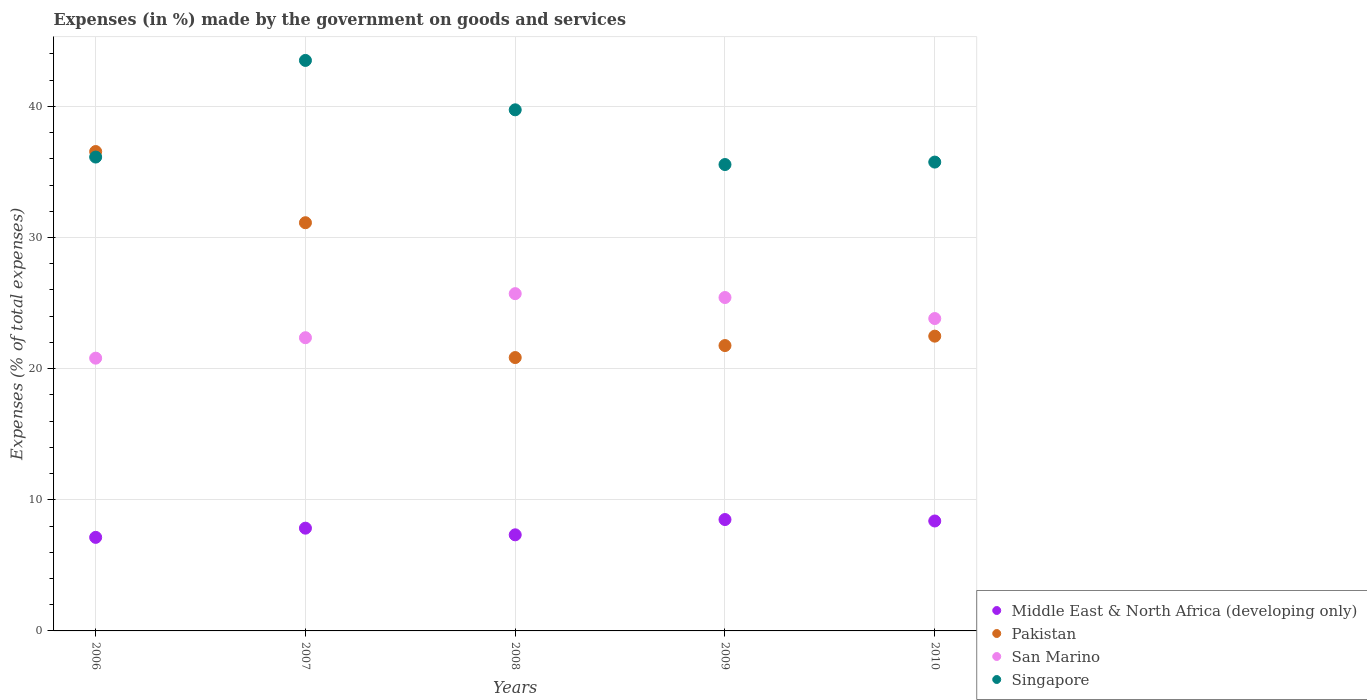What is the percentage of expenses made by the government on goods and services in San Marino in 2009?
Make the answer very short. 25.43. Across all years, what is the maximum percentage of expenses made by the government on goods and services in Pakistan?
Give a very brief answer. 36.56. Across all years, what is the minimum percentage of expenses made by the government on goods and services in Pakistan?
Provide a succinct answer. 20.85. In which year was the percentage of expenses made by the government on goods and services in San Marino minimum?
Keep it short and to the point. 2006. What is the total percentage of expenses made by the government on goods and services in Middle East & North Africa (developing only) in the graph?
Ensure brevity in your answer.  39.18. What is the difference between the percentage of expenses made by the government on goods and services in Middle East & North Africa (developing only) in 2006 and that in 2009?
Your response must be concise. -1.36. What is the difference between the percentage of expenses made by the government on goods and services in Middle East & North Africa (developing only) in 2006 and the percentage of expenses made by the government on goods and services in Singapore in 2010?
Offer a very short reply. -28.62. What is the average percentage of expenses made by the government on goods and services in Singapore per year?
Provide a short and direct response. 38.14. In the year 2010, what is the difference between the percentage of expenses made by the government on goods and services in Singapore and percentage of expenses made by the government on goods and services in Middle East & North Africa (developing only)?
Offer a very short reply. 27.37. What is the ratio of the percentage of expenses made by the government on goods and services in San Marino in 2008 to that in 2010?
Your response must be concise. 1.08. What is the difference between the highest and the second highest percentage of expenses made by the government on goods and services in Singapore?
Make the answer very short. 3.77. What is the difference between the highest and the lowest percentage of expenses made by the government on goods and services in Middle East & North Africa (developing only)?
Make the answer very short. 1.36. In how many years, is the percentage of expenses made by the government on goods and services in San Marino greater than the average percentage of expenses made by the government on goods and services in San Marino taken over all years?
Your answer should be very brief. 3. Is it the case that in every year, the sum of the percentage of expenses made by the government on goods and services in Middle East & North Africa (developing only) and percentage of expenses made by the government on goods and services in Pakistan  is greater than the sum of percentage of expenses made by the government on goods and services in Singapore and percentage of expenses made by the government on goods and services in San Marino?
Ensure brevity in your answer.  Yes. Does the percentage of expenses made by the government on goods and services in Middle East & North Africa (developing only) monotonically increase over the years?
Offer a terse response. No. Is the percentage of expenses made by the government on goods and services in San Marino strictly greater than the percentage of expenses made by the government on goods and services in Singapore over the years?
Offer a very short reply. No. How many dotlines are there?
Your answer should be very brief. 4. Does the graph contain grids?
Make the answer very short. Yes. Where does the legend appear in the graph?
Your answer should be compact. Bottom right. How are the legend labels stacked?
Keep it short and to the point. Vertical. What is the title of the graph?
Ensure brevity in your answer.  Expenses (in %) made by the government on goods and services. What is the label or title of the X-axis?
Keep it short and to the point. Years. What is the label or title of the Y-axis?
Offer a terse response. Expenses (% of total expenses). What is the Expenses (% of total expenses) of Middle East & North Africa (developing only) in 2006?
Keep it short and to the point. 7.13. What is the Expenses (% of total expenses) in Pakistan in 2006?
Your answer should be compact. 36.56. What is the Expenses (% of total expenses) of San Marino in 2006?
Make the answer very short. 20.8. What is the Expenses (% of total expenses) in Singapore in 2006?
Offer a very short reply. 36.14. What is the Expenses (% of total expenses) in Middle East & North Africa (developing only) in 2007?
Make the answer very short. 7.84. What is the Expenses (% of total expenses) of Pakistan in 2007?
Your answer should be very brief. 31.13. What is the Expenses (% of total expenses) of San Marino in 2007?
Your answer should be very brief. 22.36. What is the Expenses (% of total expenses) in Singapore in 2007?
Provide a succinct answer. 43.51. What is the Expenses (% of total expenses) in Middle East & North Africa (developing only) in 2008?
Offer a terse response. 7.33. What is the Expenses (% of total expenses) in Pakistan in 2008?
Keep it short and to the point. 20.85. What is the Expenses (% of total expenses) of San Marino in 2008?
Your response must be concise. 25.72. What is the Expenses (% of total expenses) of Singapore in 2008?
Provide a short and direct response. 39.74. What is the Expenses (% of total expenses) of Middle East & North Africa (developing only) in 2009?
Keep it short and to the point. 8.49. What is the Expenses (% of total expenses) in Pakistan in 2009?
Your answer should be very brief. 21.76. What is the Expenses (% of total expenses) of San Marino in 2009?
Provide a short and direct response. 25.43. What is the Expenses (% of total expenses) of Singapore in 2009?
Your response must be concise. 35.57. What is the Expenses (% of total expenses) of Middle East & North Africa (developing only) in 2010?
Your answer should be very brief. 8.38. What is the Expenses (% of total expenses) of Pakistan in 2010?
Your response must be concise. 22.48. What is the Expenses (% of total expenses) of San Marino in 2010?
Ensure brevity in your answer.  23.82. What is the Expenses (% of total expenses) of Singapore in 2010?
Provide a short and direct response. 35.75. Across all years, what is the maximum Expenses (% of total expenses) of Middle East & North Africa (developing only)?
Offer a very short reply. 8.49. Across all years, what is the maximum Expenses (% of total expenses) in Pakistan?
Give a very brief answer. 36.56. Across all years, what is the maximum Expenses (% of total expenses) of San Marino?
Offer a terse response. 25.72. Across all years, what is the maximum Expenses (% of total expenses) of Singapore?
Keep it short and to the point. 43.51. Across all years, what is the minimum Expenses (% of total expenses) of Middle East & North Africa (developing only)?
Your response must be concise. 7.13. Across all years, what is the minimum Expenses (% of total expenses) of Pakistan?
Keep it short and to the point. 20.85. Across all years, what is the minimum Expenses (% of total expenses) of San Marino?
Make the answer very short. 20.8. Across all years, what is the minimum Expenses (% of total expenses) of Singapore?
Your response must be concise. 35.57. What is the total Expenses (% of total expenses) of Middle East & North Africa (developing only) in the graph?
Your answer should be very brief. 39.18. What is the total Expenses (% of total expenses) in Pakistan in the graph?
Offer a terse response. 132.78. What is the total Expenses (% of total expenses) in San Marino in the graph?
Give a very brief answer. 118.13. What is the total Expenses (% of total expenses) in Singapore in the graph?
Provide a succinct answer. 190.71. What is the difference between the Expenses (% of total expenses) of Middle East & North Africa (developing only) in 2006 and that in 2007?
Your answer should be very brief. -0.7. What is the difference between the Expenses (% of total expenses) in Pakistan in 2006 and that in 2007?
Your answer should be compact. 5.43. What is the difference between the Expenses (% of total expenses) of San Marino in 2006 and that in 2007?
Give a very brief answer. -1.56. What is the difference between the Expenses (% of total expenses) in Singapore in 2006 and that in 2007?
Offer a terse response. -7.37. What is the difference between the Expenses (% of total expenses) in Middle East & North Africa (developing only) in 2006 and that in 2008?
Offer a very short reply. -0.19. What is the difference between the Expenses (% of total expenses) of Pakistan in 2006 and that in 2008?
Offer a very short reply. 15.71. What is the difference between the Expenses (% of total expenses) in San Marino in 2006 and that in 2008?
Give a very brief answer. -4.92. What is the difference between the Expenses (% of total expenses) of Singapore in 2006 and that in 2008?
Your response must be concise. -3.6. What is the difference between the Expenses (% of total expenses) in Middle East & North Africa (developing only) in 2006 and that in 2009?
Provide a short and direct response. -1.36. What is the difference between the Expenses (% of total expenses) in Pakistan in 2006 and that in 2009?
Your answer should be very brief. 14.8. What is the difference between the Expenses (% of total expenses) of San Marino in 2006 and that in 2009?
Offer a terse response. -4.62. What is the difference between the Expenses (% of total expenses) of Singapore in 2006 and that in 2009?
Your answer should be compact. 0.57. What is the difference between the Expenses (% of total expenses) of Middle East & North Africa (developing only) in 2006 and that in 2010?
Provide a short and direct response. -1.25. What is the difference between the Expenses (% of total expenses) of Pakistan in 2006 and that in 2010?
Your answer should be very brief. 14.08. What is the difference between the Expenses (% of total expenses) in San Marino in 2006 and that in 2010?
Offer a very short reply. -3.02. What is the difference between the Expenses (% of total expenses) in Singapore in 2006 and that in 2010?
Keep it short and to the point. 0.38. What is the difference between the Expenses (% of total expenses) of Middle East & North Africa (developing only) in 2007 and that in 2008?
Your answer should be compact. 0.51. What is the difference between the Expenses (% of total expenses) in Pakistan in 2007 and that in 2008?
Keep it short and to the point. 10.28. What is the difference between the Expenses (% of total expenses) of San Marino in 2007 and that in 2008?
Your answer should be very brief. -3.36. What is the difference between the Expenses (% of total expenses) in Singapore in 2007 and that in 2008?
Keep it short and to the point. 3.77. What is the difference between the Expenses (% of total expenses) of Middle East & North Africa (developing only) in 2007 and that in 2009?
Provide a succinct answer. -0.66. What is the difference between the Expenses (% of total expenses) of Pakistan in 2007 and that in 2009?
Give a very brief answer. 9.37. What is the difference between the Expenses (% of total expenses) of San Marino in 2007 and that in 2009?
Provide a succinct answer. -3.07. What is the difference between the Expenses (% of total expenses) in Singapore in 2007 and that in 2009?
Offer a very short reply. 7.94. What is the difference between the Expenses (% of total expenses) of Middle East & North Africa (developing only) in 2007 and that in 2010?
Keep it short and to the point. -0.55. What is the difference between the Expenses (% of total expenses) of Pakistan in 2007 and that in 2010?
Provide a succinct answer. 8.65. What is the difference between the Expenses (% of total expenses) of San Marino in 2007 and that in 2010?
Your answer should be very brief. -1.46. What is the difference between the Expenses (% of total expenses) in Singapore in 2007 and that in 2010?
Your response must be concise. 7.75. What is the difference between the Expenses (% of total expenses) of Middle East & North Africa (developing only) in 2008 and that in 2009?
Your answer should be compact. -1.17. What is the difference between the Expenses (% of total expenses) in Pakistan in 2008 and that in 2009?
Your answer should be compact. -0.92. What is the difference between the Expenses (% of total expenses) of San Marino in 2008 and that in 2009?
Give a very brief answer. 0.29. What is the difference between the Expenses (% of total expenses) in Singapore in 2008 and that in 2009?
Offer a terse response. 4.17. What is the difference between the Expenses (% of total expenses) in Middle East & North Africa (developing only) in 2008 and that in 2010?
Offer a terse response. -1.06. What is the difference between the Expenses (% of total expenses) of Pakistan in 2008 and that in 2010?
Your answer should be very brief. -1.63. What is the difference between the Expenses (% of total expenses) of San Marino in 2008 and that in 2010?
Offer a very short reply. 1.9. What is the difference between the Expenses (% of total expenses) of Singapore in 2008 and that in 2010?
Offer a very short reply. 3.99. What is the difference between the Expenses (% of total expenses) of Middle East & North Africa (developing only) in 2009 and that in 2010?
Ensure brevity in your answer.  0.11. What is the difference between the Expenses (% of total expenses) in Pakistan in 2009 and that in 2010?
Offer a terse response. -0.72. What is the difference between the Expenses (% of total expenses) of San Marino in 2009 and that in 2010?
Provide a succinct answer. 1.6. What is the difference between the Expenses (% of total expenses) in Singapore in 2009 and that in 2010?
Provide a succinct answer. -0.19. What is the difference between the Expenses (% of total expenses) of Middle East & North Africa (developing only) in 2006 and the Expenses (% of total expenses) of Pakistan in 2007?
Give a very brief answer. -24. What is the difference between the Expenses (% of total expenses) of Middle East & North Africa (developing only) in 2006 and the Expenses (% of total expenses) of San Marino in 2007?
Provide a succinct answer. -15.23. What is the difference between the Expenses (% of total expenses) of Middle East & North Africa (developing only) in 2006 and the Expenses (% of total expenses) of Singapore in 2007?
Your response must be concise. -36.37. What is the difference between the Expenses (% of total expenses) of Pakistan in 2006 and the Expenses (% of total expenses) of San Marino in 2007?
Provide a short and direct response. 14.2. What is the difference between the Expenses (% of total expenses) of Pakistan in 2006 and the Expenses (% of total expenses) of Singapore in 2007?
Ensure brevity in your answer.  -6.95. What is the difference between the Expenses (% of total expenses) of San Marino in 2006 and the Expenses (% of total expenses) of Singapore in 2007?
Provide a short and direct response. -22.71. What is the difference between the Expenses (% of total expenses) in Middle East & North Africa (developing only) in 2006 and the Expenses (% of total expenses) in Pakistan in 2008?
Provide a short and direct response. -13.71. What is the difference between the Expenses (% of total expenses) of Middle East & North Africa (developing only) in 2006 and the Expenses (% of total expenses) of San Marino in 2008?
Provide a succinct answer. -18.59. What is the difference between the Expenses (% of total expenses) of Middle East & North Africa (developing only) in 2006 and the Expenses (% of total expenses) of Singapore in 2008?
Keep it short and to the point. -32.61. What is the difference between the Expenses (% of total expenses) in Pakistan in 2006 and the Expenses (% of total expenses) in San Marino in 2008?
Your answer should be very brief. 10.84. What is the difference between the Expenses (% of total expenses) in Pakistan in 2006 and the Expenses (% of total expenses) in Singapore in 2008?
Provide a succinct answer. -3.18. What is the difference between the Expenses (% of total expenses) in San Marino in 2006 and the Expenses (% of total expenses) in Singapore in 2008?
Ensure brevity in your answer.  -18.94. What is the difference between the Expenses (% of total expenses) of Middle East & North Africa (developing only) in 2006 and the Expenses (% of total expenses) of Pakistan in 2009?
Ensure brevity in your answer.  -14.63. What is the difference between the Expenses (% of total expenses) in Middle East & North Africa (developing only) in 2006 and the Expenses (% of total expenses) in San Marino in 2009?
Ensure brevity in your answer.  -18.29. What is the difference between the Expenses (% of total expenses) in Middle East & North Africa (developing only) in 2006 and the Expenses (% of total expenses) in Singapore in 2009?
Keep it short and to the point. -28.43. What is the difference between the Expenses (% of total expenses) of Pakistan in 2006 and the Expenses (% of total expenses) of San Marino in 2009?
Provide a succinct answer. 11.13. What is the difference between the Expenses (% of total expenses) of Pakistan in 2006 and the Expenses (% of total expenses) of Singapore in 2009?
Provide a succinct answer. 0.99. What is the difference between the Expenses (% of total expenses) of San Marino in 2006 and the Expenses (% of total expenses) of Singapore in 2009?
Provide a succinct answer. -14.77. What is the difference between the Expenses (% of total expenses) in Middle East & North Africa (developing only) in 2006 and the Expenses (% of total expenses) in Pakistan in 2010?
Provide a short and direct response. -15.34. What is the difference between the Expenses (% of total expenses) of Middle East & North Africa (developing only) in 2006 and the Expenses (% of total expenses) of San Marino in 2010?
Your response must be concise. -16.69. What is the difference between the Expenses (% of total expenses) in Middle East & North Africa (developing only) in 2006 and the Expenses (% of total expenses) in Singapore in 2010?
Give a very brief answer. -28.62. What is the difference between the Expenses (% of total expenses) of Pakistan in 2006 and the Expenses (% of total expenses) of San Marino in 2010?
Keep it short and to the point. 12.74. What is the difference between the Expenses (% of total expenses) of Pakistan in 2006 and the Expenses (% of total expenses) of Singapore in 2010?
Provide a short and direct response. 0.8. What is the difference between the Expenses (% of total expenses) in San Marino in 2006 and the Expenses (% of total expenses) in Singapore in 2010?
Provide a short and direct response. -14.95. What is the difference between the Expenses (% of total expenses) in Middle East & North Africa (developing only) in 2007 and the Expenses (% of total expenses) in Pakistan in 2008?
Your answer should be compact. -13.01. What is the difference between the Expenses (% of total expenses) in Middle East & North Africa (developing only) in 2007 and the Expenses (% of total expenses) in San Marino in 2008?
Give a very brief answer. -17.88. What is the difference between the Expenses (% of total expenses) in Middle East & North Africa (developing only) in 2007 and the Expenses (% of total expenses) in Singapore in 2008?
Give a very brief answer. -31.9. What is the difference between the Expenses (% of total expenses) in Pakistan in 2007 and the Expenses (% of total expenses) in San Marino in 2008?
Provide a succinct answer. 5.41. What is the difference between the Expenses (% of total expenses) of Pakistan in 2007 and the Expenses (% of total expenses) of Singapore in 2008?
Make the answer very short. -8.61. What is the difference between the Expenses (% of total expenses) of San Marino in 2007 and the Expenses (% of total expenses) of Singapore in 2008?
Ensure brevity in your answer.  -17.38. What is the difference between the Expenses (% of total expenses) in Middle East & North Africa (developing only) in 2007 and the Expenses (% of total expenses) in Pakistan in 2009?
Your answer should be very brief. -13.93. What is the difference between the Expenses (% of total expenses) of Middle East & North Africa (developing only) in 2007 and the Expenses (% of total expenses) of San Marino in 2009?
Give a very brief answer. -17.59. What is the difference between the Expenses (% of total expenses) in Middle East & North Africa (developing only) in 2007 and the Expenses (% of total expenses) in Singapore in 2009?
Your response must be concise. -27.73. What is the difference between the Expenses (% of total expenses) of Pakistan in 2007 and the Expenses (% of total expenses) of San Marino in 2009?
Keep it short and to the point. 5.7. What is the difference between the Expenses (% of total expenses) in Pakistan in 2007 and the Expenses (% of total expenses) in Singapore in 2009?
Your answer should be compact. -4.44. What is the difference between the Expenses (% of total expenses) of San Marino in 2007 and the Expenses (% of total expenses) of Singapore in 2009?
Provide a succinct answer. -13.21. What is the difference between the Expenses (% of total expenses) of Middle East & North Africa (developing only) in 2007 and the Expenses (% of total expenses) of Pakistan in 2010?
Your response must be concise. -14.64. What is the difference between the Expenses (% of total expenses) of Middle East & North Africa (developing only) in 2007 and the Expenses (% of total expenses) of San Marino in 2010?
Give a very brief answer. -15.99. What is the difference between the Expenses (% of total expenses) in Middle East & North Africa (developing only) in 2007 and the Expenses (% of total expenses) in Singapore in 2010?
Make the answer very short. -27.92. What is the difference between the Expenses (% of total expenses) of Pakistan in 2007 and the Expenses (% of total expenses) of San Marino in 2010?
Your answer should be very brief. 7.31. What is the difference between the Expenses (% of total expenses) in Pakistan in 2007 and the Expenses (% of total expenses) in Singapore in 2010?
Provide a short and direct response. -4.62. What is the difference between the Expenses (% of total expenses) in San Marino in 2007 and the Expenses (% of total expenses) in Singapore in 2010?
Provide a short and direct response. -13.39. What is the difference between the Expenses (% of total expenses) of Middle East & North Africa (developing only) in 2008 and the Expenses (% of total expenses) of Pakistan in 2009?
Your answer should be compact. -14.43. What is the difference between the Expenses (% of total expenses) in Middle East & North Africa (developing only) in 2008 and the Expenses (% of total expenses) in San Marino in 2009?
Your answer should be compact. -18.1. What is the difference between the Expenses (% of total expenses) of Middle East & North Africa (developing only) in 2008 and the Expenses (% of total expenses) of Singapore in 2009?
Your answer should be very brief. -28.24. What is the difference between the Expenses (% of total expenses) in Pakistan in 2008 and the Expenses (% of total expenses) in San Marino in 2009?
Your response must be concise. -4.58. What is the difference between the Expenses (% of total expenses) in Pakistan in 2008 and the Expenses (% of total expenses) in Singapore in 2009?
Provide a short and direct response. -14.72. What is the difference between the Expenses (% of total expenses) in San Marino in 2008 and the Expenses (% of total expenses) in Singapore in 2009?
Offer a terse response. -9.85. What is the difference between the Expenses (% of total expenses) in Middle East & North Africa (developing only) in 2008 and the Expenses (% of total expenses) in Pakistan in 2010?
Offer a terse response. -15.15. What is the difference between the Expenses (% of total expenses) of Middle East & North Africa (developing only) in 2008 and the Expenses (% of total expenses) of San Marino in 2010?
Keep it short and to the point. -16.49. What is the difference between the Expenses (% of total expenses) in Middle East & North Africa (developing only) in 2008 and the Expenses (% of total expenses) in Singapore in 2010?
Give a very brief answer. -28.43. What is the difference between the Expenses (% of total expenses) of Pakistan in 2008 and the Expenses (% of total expenses) of San Marino in 2010?
Your answer should be very brief. -2.98. What is the difference between the Expenses (% of total expenses) in Pakistan in 2008 and the Expenses (% of total expenses) in Singapore in 2010?
Your answer should be compact. -14.91. What is the difference between the Expenses (% of total expenses) of San Marino in 2008 and the Expenses (% of total expenses) of Singapore in 2010?
Keep it short and to the point. -10.03. What is the difference between the Expenses (% of total expenses) in Middle East & North Africa (developing only) in 2009 and the Expenses (% of total expenses) in Pakistan in 2010?
Provide a short and direct response. -13.99. What is the difference between the Expenses (% of total expenses) of Middle East & North Africa (developing only) in 2009 and the Expenses (% of total expenses) of San Marino in 2010?
Give a very brief answer. -15.33. What is the difference between the Expenses (% of total expenses) of Middle East & North Africa (developing only) in 2009 and the Expenses (% of total expenses) of Singapore in 2010?
Offer a terse response. -27.26. What is the difference between the Expenses (% of total expenses) of Pakistan in 2009 and the Expenses (% of total expenses) of San Marino in 2010?
Offer a terse response. -2.06. What is the difference between the Expenses (% of total expenses) of Pakistan in 2009 and the Expenses (% of total expenses) of Singapore in 2010?
Provide a succinct answer. -13.99. What is the difference between the Expenses (% of total expenses) in San Marino in 2009 and the Expenses (% of total expenses) in Singapore in 2010?
Offer a very short reply. -10.33. What is the average Expenses (% of total expenses) of Middle East & North Africa (developing only) per year?
Your answer should be very brief. 7.84. What is the average Expenses (% of total expenses) of Pakistan per year?
Offer a terse response. 26.56. What is the average Expenses (% of total expenses) in San Marino per year?
Your answer should be very brief. 23.63. What is the average Expenses (% of total expenses) in Singapore per year?
Offer a terse response. 38.14. In the year 2006, what is the difference between the Expenses (% of total expenses) in Middle East & North Africa (developing only) and Expenses (% of total expenses) in Pakistan?
Ensure brevity in your answer.  -29.42. In the year 2006, what is the difference between the Expenses (% of total expenses) of Middle East & North Africa (developing only) and Expenses (% of total expenses) of San Marino?
Ensure brevity in your answer.  -13.67. In the year 2006, what is the difference between the Expenses (% of total expenses) of Middle East & North Africa (developing only) and Expenses (% of total expenses) of Singapore?
Your answer should be compact. -29. In the year 2006, what is the difference between the Expenses (% of total expenses) of Pakistan and Expenses (% of total expenses) of San Marino?
Your answer should be very brief. 15.76. In the year 2006, what is the difference between the Expenses (% of total expenses) in Pakistan and Expenses (% of total expenses) in Singapore?
Provide a short and direct response. 0.42. In the year 2006, what is the difference between the Expenses (% of total expenses) of San Marino and Expenses (% of total expenses) of Singapore?
Your answer should be very brief. -15.34. In the year 2007, what is the difference between the Expenses (% of total expenses) of Middle East & North Africa (developing only) and Expenses (% of total expenses) of Pakistan?
Provide a short and direct response. -23.29. In the year 2007, what is the difference between the Expenses (% of total expenses) in Middle East & North Africa (developing only) and Expenses (% of total expenses) in San Marino?
Your answer should be very brief. -14.52. In the year 2007, what is the difference between the Expenses (% of total expenses) in Middle East & North Africa (developing only) and Expenses (% of total expenses) in Singapore?
Give a very brief answer. -35.67. In the year 2007, what is the difference between the Expenses (% of total expenses) of Pakistan and Expenses (% of total expenses) of San Marino?
Your answer should be compact. 8.77. In the year 2007, what is the difference between the Expenses (% of total expenses) in Pakistan and Expenses (% of total expenses) in Singapore?
Keep it short and to the point. -12.38. In the year 2007, what is the difference between the Expenses (% of total expenses) of San Marino and Expenses (% of total expenses) of Singapore?
Your answer should be compact. -21.15. In the year 2008, what is the difference between the Expenses (% of total expenses) of Middle East & North Africa (developing only) and Expenses (% of total expenses) of Pakistan?
Make the answer very short. -13.52. In the year 2008, what is the difference between the Expenses (% of total expenses) of Middle East & North Africa (developing only) and Expenses (% of total expenses) of San Marino?
Your answer should be compact. -18.39. In the year 2008, what is the difference between the Expenses (% of total expenses) in Middle East & North Africa (developing only) and Expenses (% of total expenses) in Singapore?
Your answer should be very brief. -32.41. In the year 2008, what is the difference between the Expenses (% of total expenses) in Pakistan and Expenses (% of total expenses) in San Marino?
Keep it short and to the point. -4.87. In the year 2008, what is the difference between the Expenses (% of total expenses) of Pakistan and Expenses (% of total expenses) of Singapore?
Provide a short and direct response. -18.89. In the year 2008, what is the difference between the Expenses (% of total expenses) of San Marino and Expenses (% of total expenses) of Singapore?
Make the answer very short. -14.02. In the year 2009, what is the difference between the Expenses (% of total expenses) of Middle East & North Africa (developing only) and Expenses (% of total expenses) of Pakistan?
Give a very brief answer. -13.27. In the year 2009, what is the difference between the Expenses (% of total expenses) in Middle East & North Africa (developing only) and Expenses (% of total expenses) in San Marino?
Your answer should be very brief. -16.93. In the year 2009, what is the difference between the Expenses (% of total expenses) of Middle East & North Africa (developing only) and Expenses (% of total expenses) of Singapore?
Give a very brief answer. -27.07. In the year 2009, what is the difference between the Expenses (% of total expenses) of Pakistan and Expenses (% of total expenses) of San Marino?
Provide a short and direct response. -3.66. In the year 2009, what is the difference between the Expenses (% of total expenses) of Pakistan and Expenses (% of total expenses) of Singapore?
Offer a terse response. -13.81. In the year 2009, what is the difference between the Expenses (% of total expenses) of San Marino and Expenses (% of total expenses) of Singapore?
Keep it short and to the point. -10.14. In the year 2010, what is the difference between the Expenses (% of total expenses) in Middle East & North Africa (developing only) and Expenses (% of total expenses) in Pakistan?
Your answer should be compact. -14.1. In the year 2010, what is the difference between the Expenses (% of total expenses) of Middle East & North Africa (developing only) and Expenses (% of total expenses) of San Marino?
Your answer should be compact. -15.44. In the year 2010, what is the difference between the Expenses (% of total expenses) of Middle East & North Africa (developing only) and Expenses (% of total expenses) of Singapore?
Ensure brevity in your answer.  -27.37. In the year 2010, what is the difference between the Expenses (% of total expenses) of Pakistan and Expenses (% of total expenses) of San Marino?
Make the answer very short. -1.34. In the year 2010, what is the difference between the Expenses (% of total expenses) of Pakistan and Expenses (% of total expenses) of Singapore?
Your answer should be compact. -13.28. In the year 2010, what is the difference between the Expenses (% of total expenses) in San Marino and Expenses (% of total expenses) in Singapore?
Ensure brevity in your answer.  -11.93. What is the ratio of the Expenses (% of total expenses) of Middle East & North Africa (developing only) in 2006 to that in 2007?
Provide a short and direct response. 0.91. What is the ratio of the Expenses (% of total expenses) in Pakistan in 2006 to that in 2007?
Offer a terse response. 1.17. What is the ratio of the Expenses (% of total expenses) in San Marino in 2006 to that in 2007?
Give a very brief answer. 0.93. What is the ratio of the Expenses (% of total expenses) of Singapore in 2006 to that in 2007?
Give a very brief answer. 0.83. What is the ratio of the Expenses (% of total expenses) of Middle East & North Africa (developing only) in 2006 to that in 2008?
Give a very brief answer. 0.97. What is the ratio of the Expenses (% of total expenses) of Pakistan in 2006 to that in 2008?
Your answer should be compact. 1.75. What is the ratio of the Expenses (% of total expenses) of San Marino in 2006 to that in 2008?
Provide a succinct answer. 0.81. What is the ratio of the Expenses (% of total expenses) in Singapore in 2006 to that in 2008?
Your response must be concise. 0.91. What is the ratio of the Expenses (% of total expenses) in Middle East & North Africa (developing only) in 2006 to that in 2009?
Your answer should be very brief. 0.84. What is the ratio of the Expenses (% of total expenses) in Pakistan in 2006 to that in 2009?
Make the answer very short. 1.68. What is the ratio of the Expenses (% of total expenses) of San Marino in 2006 to that in 2009?
Your answer should be compact. 0.82. What is the ratio of the Expenses (% of total expenses) in Singapore in 2006 to that in 2009?
Your answer should be compact. 1.02. What is the ratio of the Expenses (% of total expenses) in Middle East & North Africa (developing only) in 2006 to that in 2010?
Offer a very short reply. 0.85. What is the ratio of the Expenses (% of total expenses) in Pakistan in 2006 to that in 2010?
Offer a very short reply. 1.63. What is the ratio of the Expenses (% of total expenses) in San Marino in 2006 to that in 2010?
Your answer should be very brief. 0.87. What is the ratio of the Expenses (% of total expenses) in Singapore in 2006 to that in 2010?
Offer a terse response. 1.01. What is the ratio of the Expenses (% of total expenses) in Middle East & North Africa (developing only) in 2007 to that in 2008?
Make the answer very short. 1.07. What is the ratio of the Expenses (% of total expenses) of Pakistan in 2007 to that in 2008?
Offer a terse response. 1.49. What is the ratio of the Expenses (% of total expenses) of San Marino in 2007 to that in 2008?
Ensure brevity in your answer.  0.87. What is the ratio of the Expenses (% of total expenses) of Singapore in 2007 to that in 2008?
Your response must be concise. 1.09. What is the ratio of the Expenses (% of total expenses) in Middle East & North Africa (developing only) in 2007 to that in 2009?
Your response must be concise. 0.92. What is the ratio of the Expenses (% of total expenses) in Pakistan in 2007 to that in 2009?
Your answer should be very brief. 1.43. What is the ratio of the Expenses (% of total expenses) of San Marino in 2007 to that in 2009?
Your response must be concise. 0.88. What is the ratio of the Expenses (% of total expenses) in Singapore in 2007 to that in 2009?
Give a very brief answer. 1.22. What is the ratio of the Expenses (% of total expenses) of Middle East & North Africa (developing only) in 2007 to that in 2010?
Your answer should be compact. 0.93. What is the ratio of the Expenses (% of total expenses) in Pakistan in 2007 to that in 2010?
Your answer should be very brief. 1.38. What is the ratio of the Expenses (% of total expenses) of San Marino in 2007 to that in 2010?
Your answer should be very brief. 0.94. What is the ratio of the Expenses (% of total expenses) in Singapore in 2007 to that in 2010?
Provide a succinct answer. 1.22. What is the ratio of the Expenses (% of total expenses) of Middle East & North Africa (developing only) in 2008 to that in 2009?
Ensure brevity in your answer.  0.86. What is the ratio of the Expenses (% of total expenses) in Pakistan in 2008 to that in 2009?
Ensure brevity in your answer.  0.96. What is the ratio of the Expenses (% of total expenses) of San Marino in 2008 to that in 2009?
Make the answer very short. 1.01. What is the ratio of the Expenses (% of total expenses) of Singapore in 2008 to that in 2009?
Ensure brevity in your answer.  1.12. What is the ratio of the Expenses (% of total expenses) in Middle East & North Africa (developing only) in 2008 to that in 2010?
Offer a terse response. 0.87. What is the ratio of the Expenses (% of total expenses) of Pakistan in 2008 to that in 2010?
Make the answer very short. 0.93. What is the ratio of the Expenses (% of total expenses) in San Marino in 2008 to that in 2010?
Provide a succinct answer. 1.08. What is the ratio of the Expenses (% of total expenses) in Singapore in 2008 to that in 2010?
Ensure brevity in your answer.  1.11. What is the ratio of the Expenses (% of total expenses) in Middle East & North Africa (developing only) in 2009 to that in 2010?
Your answer should be very brief. 1.01. What is the ratio of the Expenses (% of total expenses) of Pakistan in 2009 to that in 2010?
Offer a terse response. 0.97. What is the ratio of the Expenses (% of total expenses) in San Marino in 2009 to that in 2010?
Provide a short and direct response. 1.07. What is the ratio of the Expenses (% of total expenses) of Singapore in 2009 to that in 2010?
Your response must be concise. 0.99. What is the difference between the highest and the second highest Expenses (% of total expenses) of Middle East & North Africa (developing only)?
Give a very brief answer. 0.11. What is the difference between the highest and the second highest Expenses (% of total expenses) of Pakistan?
Offer a very short reply. 5.43. What is the difference between the highest and the second highest Expenses (% of total expenses) of San Marino?
Make the answer very short. 0.29. What is the difference between the highest and the second highest Expenses (% of total expenses) of Singapore?
Offer a very short reply. 3.77. What is the difference between the highest and the lowest Expenses (% of total expenses) in Middle East & North Africa (developing only)?
Your answer should be compact. 1.36. What is the difference between the highest and the lowest Expenses (% of total expenses) in Pakistan?
Offer a very short reply. 15.71. What is the difference between the highest and the lowest Expenses (% of total expenses) in San Marino?
Provide a succinct answer. 4.92. What is the difference between the highest and the lowest Expenses (% of total expenses) of Singapore?
Provide a short and direct response. 7.94. 